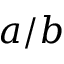<formula> <loc_0><loc_0><loc_500><loc_500>a / b</formula> 